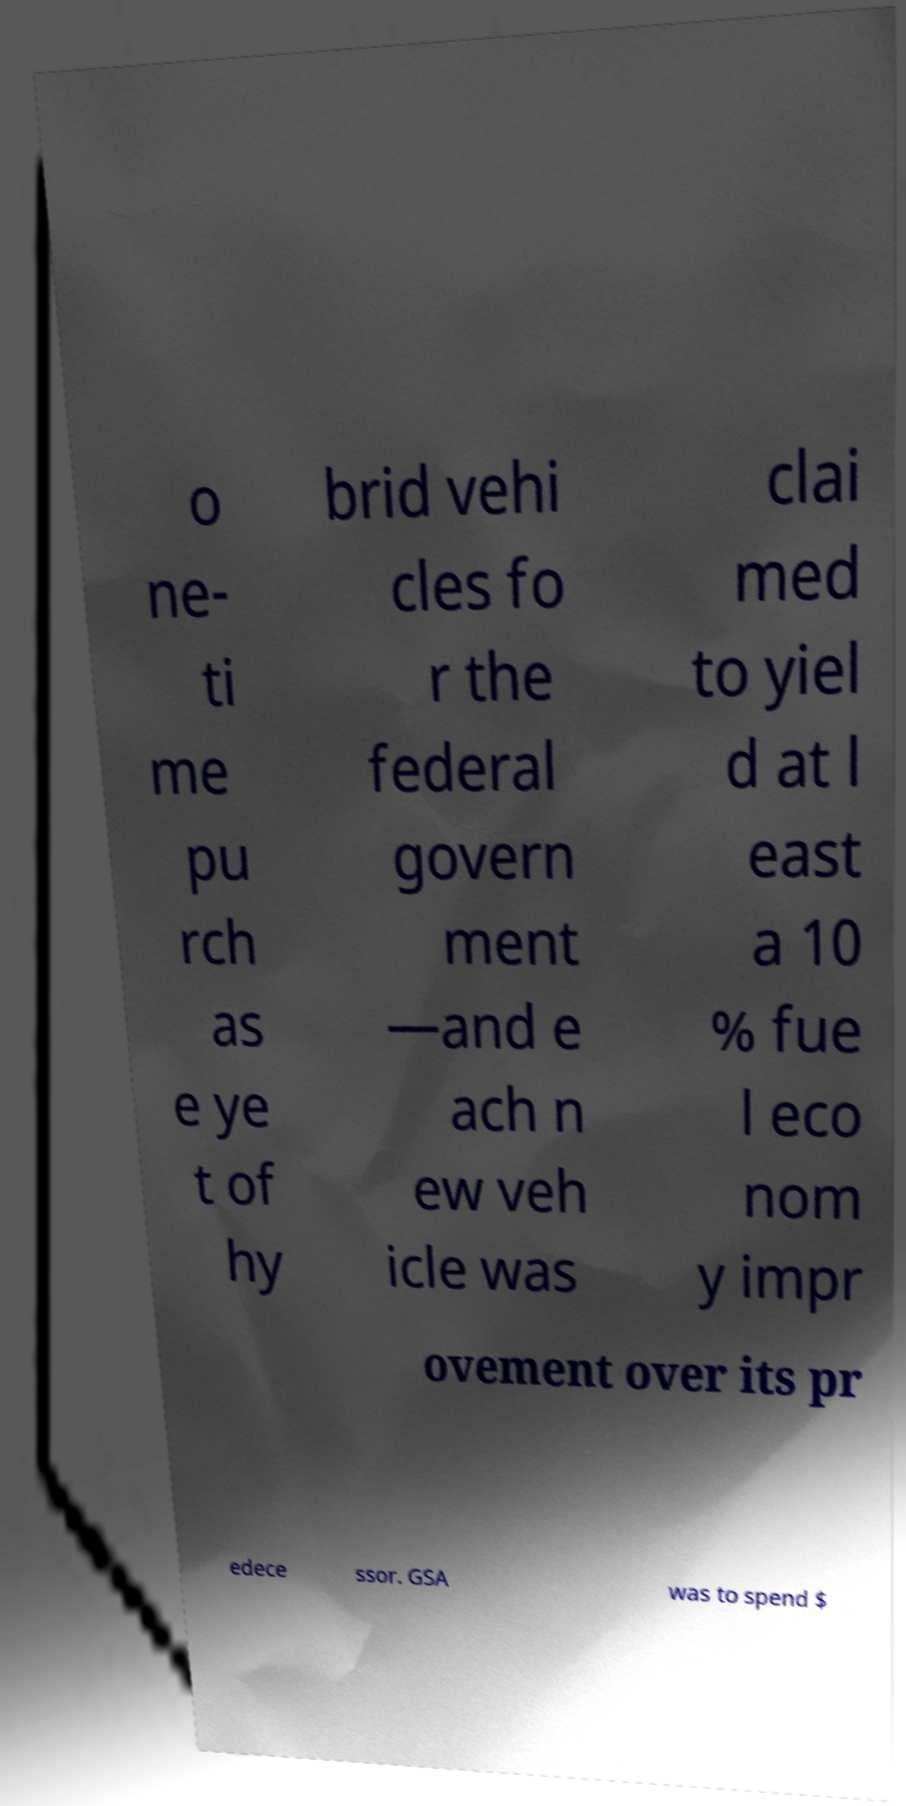Could you extract and type out the text from this image? o ne- ti me pu rch as e ye t of hy brid vehi cles fo r the federal govern ment —and e ach n ew veh icle was clai med to yiel d at l east a 10 % fue l eco nom y impr ovement over its pr edece ssor. GSA was to spend $ 